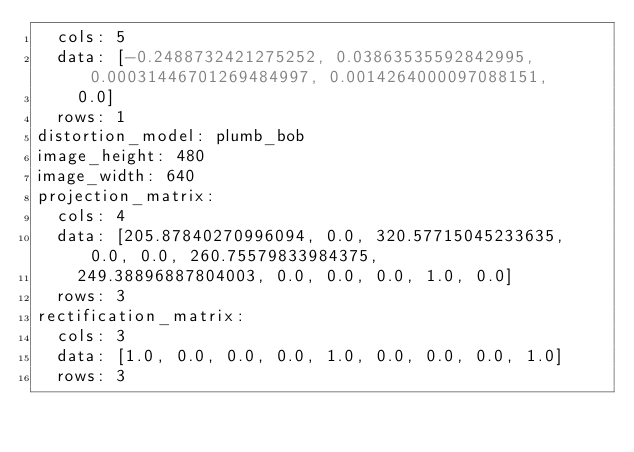<code> <loc_0><loc_0><loc_500><loc_500><_YAML_>  cols: 5
  data: [-0.2488732421275252, 0.03863535592842995, 0.00031446701269484997, 0.0014264000097088151,
    0.0]
  rows: 1
distortion_model: plumb_bob
image_height: 480
image_width: 640
projection_matrix:
  cols: 4
  data: [205.87840270996094, 0.0, 320.57715045233635, 0.0, 0.0, 260.75579833984375,
    249.38896887804003, 0.0, 0.0, 0.0, 1.0, 0.0]
  rows: 3
rectification_matrix:
  cols: 3
  data: [1.0, 0.0, 0.0, 0.0, 1.0, 0.0, 0.0, 0.0, 1.0]
  rows: 3
</code> 